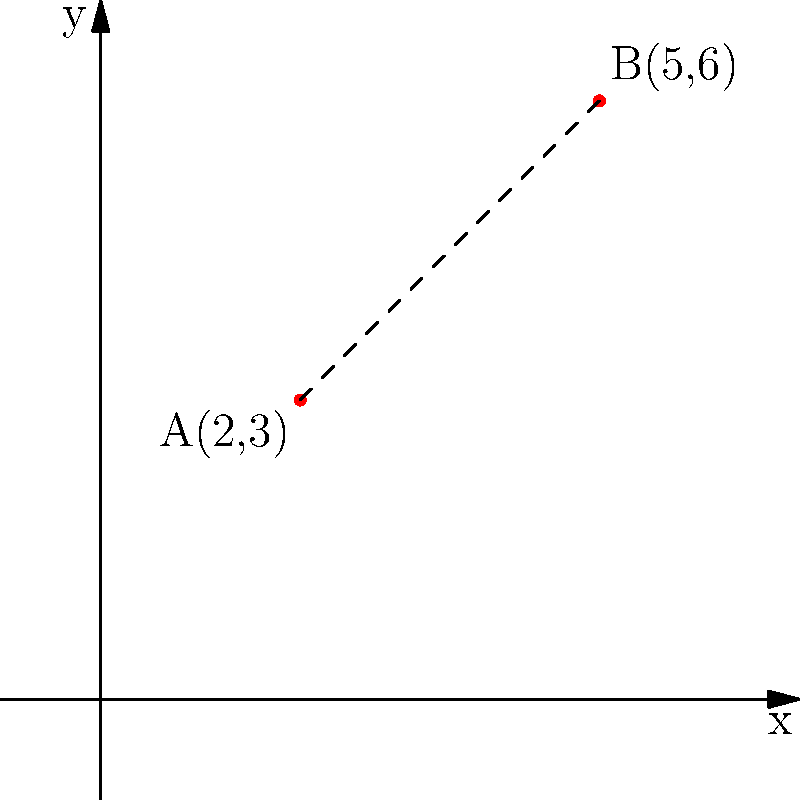As a cookbook editor, you're reviewing a dessert photograph where two berries are strategically placed as garnishes. The photographer has provided you with the coordinates of these berries on a grid overlay. Berry A is located at (2,3) and Berry B is at (5,6). Using the distance formula, calculate the exact distance between these two berries to appreciate the precise positioning in the photograph. To find the distance between two points, we use the distance formula:

$d = \sqrt{(x_2-x_1)^2 + (y_2-y_1)^2}$

Where $(x_1,y_1)$ is the coordinate of the first point and $(x_2,y_2)$ is the coordinate of the second point.

Step 1: Identify the coordinates
Berry A: $(x_1,y_1) = (2,3)$
Berry B: $(x_2,y_2) = (5,6)$

Step 2: Plug the coordinates into the formula
$d = \sqrt{(5-2)^2 + (6-3)^2}$

Step 3: Simplify inside the parentheses
$d = \sqrt{3^2 + 3^2}$

Step 4: Calculate the squares
$d = \sqrt{9 + 9}$

Step 5: Add under the square root
$d = \sqrt{18}$

Step 6: Simplify the square root
$d = 3\sqrt{2}$

Therefore, the exact distance between the two berries is $3\sqrt{2}$ units.
Answer: $3\sqrt{2}$ units 